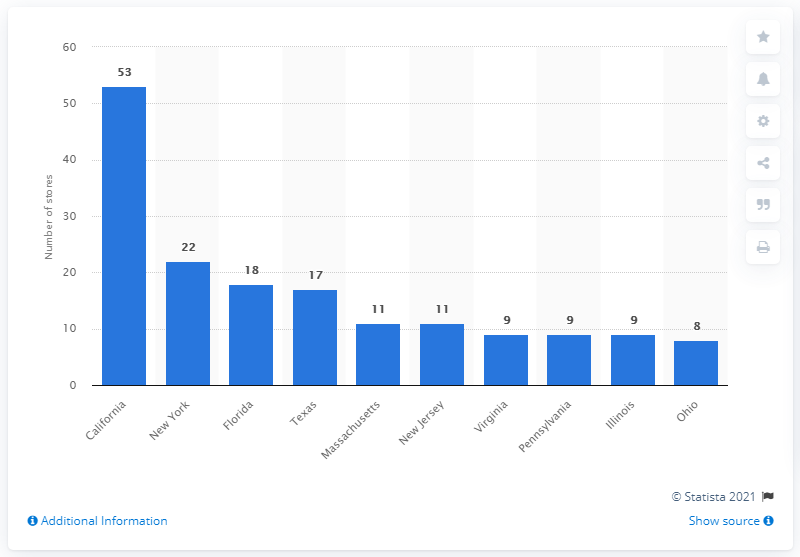Give some essential details in this illustration. There are 53 Apple Store locations in the state of California. 